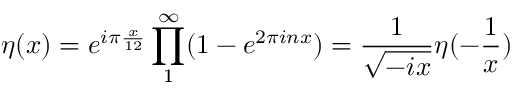<formula> <loc_0><loc_0><loc_500><loc_500>\eta ( x ) = e ^ { i \pi \frac { x } { 1 2 } } \prod _ { 1 } ^ { \infty } ( 1 - e ^ { 2 \pi i n x } ) = \frac { 1 } { \sqrt { - i x } } \eta ( - \frac { 1 } { x } )</formula> 